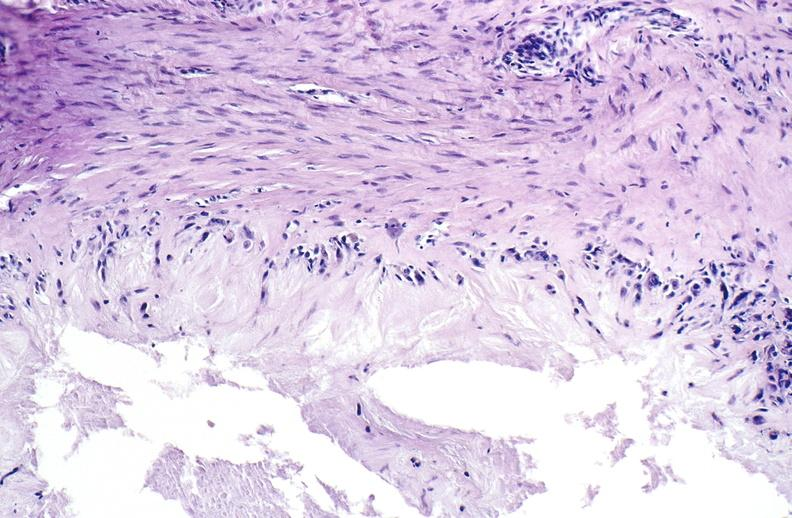what is present?
Answer the question using a single word or phrase. Joints 